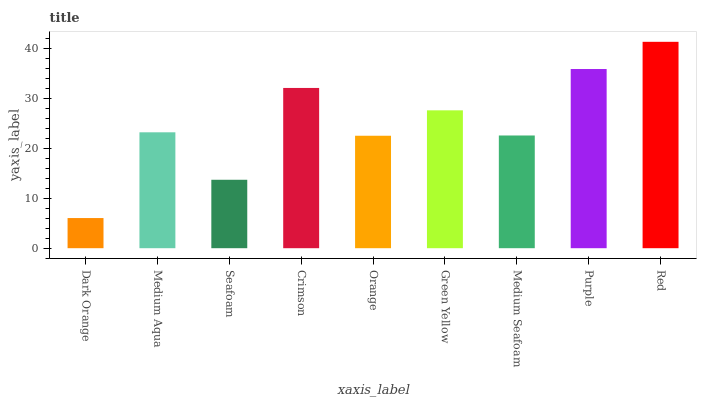Is Dark Orange the minimum?
Answer yes or no. Yes. Is Red the maximum?
Answer yes or no. Yes. Is Medium Aqua the minimum?
Answer yes or no. No. Is Medium Aqua the maximum?
Answer yes or no. No. Is Medium Aqua greater than Dark Orange?
Answer yes or no. Yes. Is Dark Orange less than Medium Aqua?
Answer yes or no. Yes. Is Dark Orange greater than Medium Aqua?
Answer yes or no. No. Is Medium Aqua less than Dark Orange?
Answer yes or no. No. Is Medium Aqua the high median?
Answer yes or no. Yes. Is Medium Aqua the low median?
Answer yes or no. Yes. Is Red the high median?
Answer yes or no. No. Is Crimson the low median?
Answer yes or no. No. 